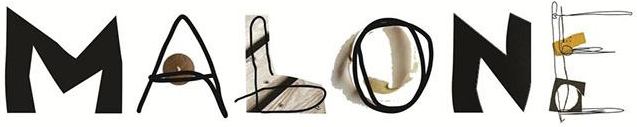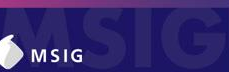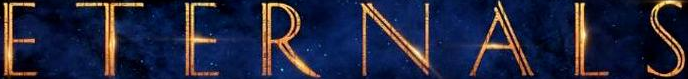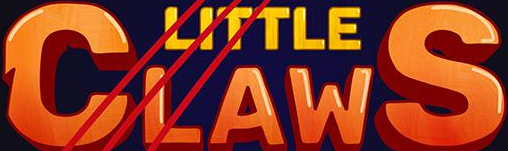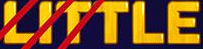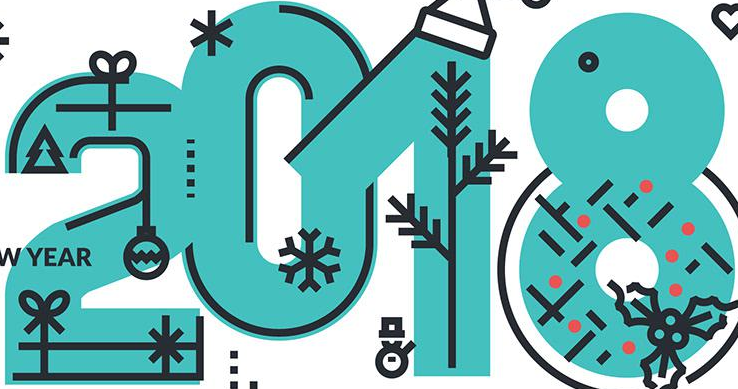What words are shown in these images in order, separated by a semicolon? MALONE; MSIG; ETERNALS; CLAWS; LITTLE; 2018 